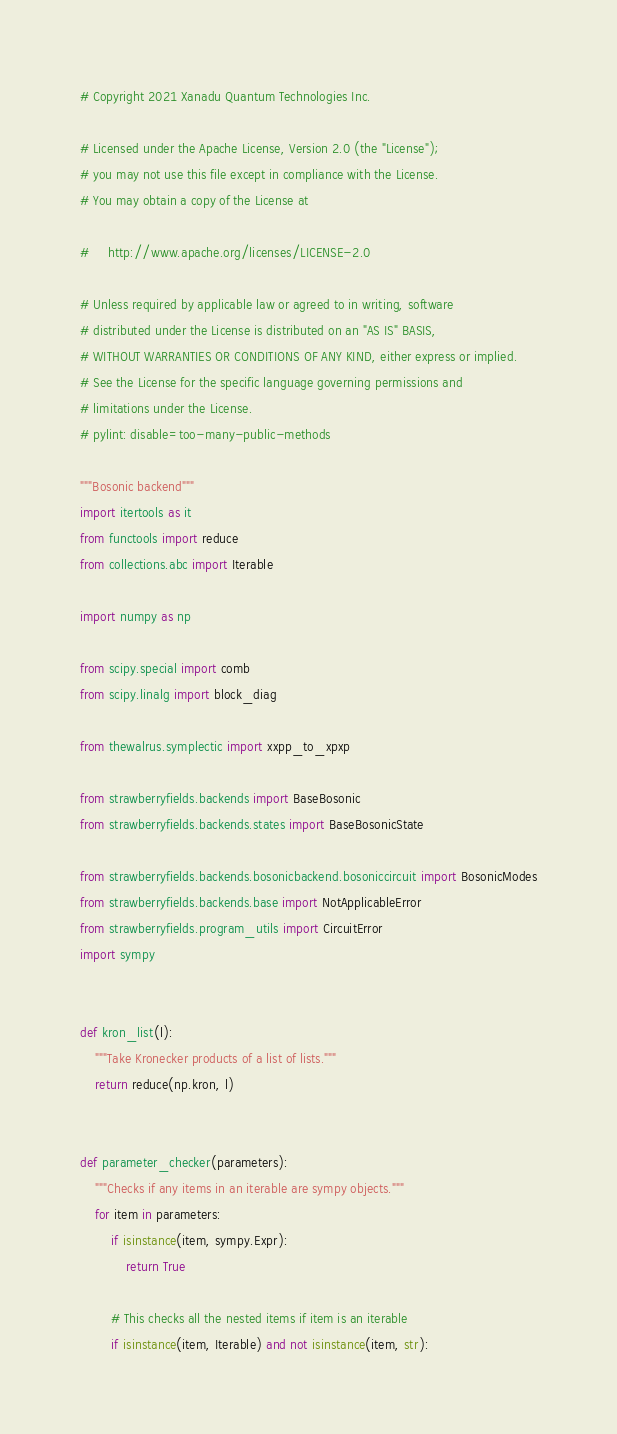Convert code to text. <code><loc_0><loc_0><loc_500><loc_500><_Python_># Copyright 2021 Xanadu Quantum Technologies Inc.

# Licensed under the Apache License, Version 2.0 (the "License");
# you may not use this file except in compliance with the License.
# You may obtain a copy of the License at

#     http://www.apache.org/licenses/LICENSE-2.0

# Unless required by applicable law or agreed to in writing, software
# distributed under the License is distributed on an "AS IS" BASIS,
# WITHOUT WARRANTIES OR CONDITIONS OF ANY KIND, either express or implied.
# See the License for the specific language governing permissions and
# limitations under the License.
# pylint: disable=too-many-public-methods

"""Bosonic backend"""
import itertools as it
from functools import reduce
from collections.abc import Iterable

import numpy as np

from scipy.special import comb
from scipy.linalg import block_diag

from thewalrus.symplectic import xxpp_to_xpxp

from strawberryfields.backends import BaseBosonic
from strawberryfields.backends.states import BaseBosonicState

from strawberryfields.backends.bosonicbackend.bosoniccircuit import BosonicModes
from strawberryfields.backends.base import NotApplicableError
from strawberryfields.program_utils import CircuitError
import sympy


def kron_list(l):
    """Take Kronecker products of a list of lists."""
    return reduce(np.kron, l)


def parameter_checker(parameters):
    """Checks if any items in an iterable are sympy objects."""
    for item in parameters:
        if isinstance(item, sympy.Expr):
            return True

        # This checks all the nested items if item is an iterable
        if isinstance(item, Iterable) and not isinstance(item, str):</code> 